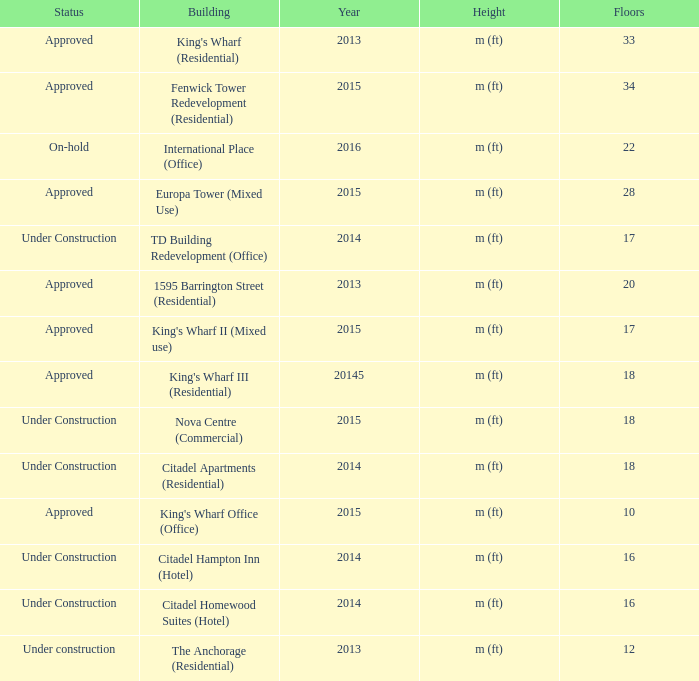What are the number of floors for the building of td building redevelopment (office)? 17.0. 